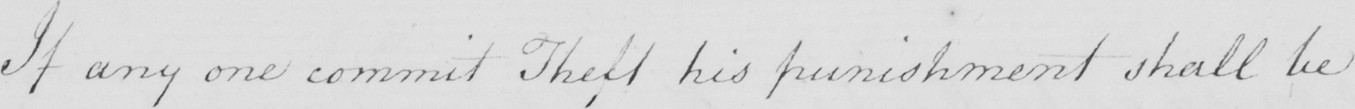What is written in this line of handwriting? If any one commit Theft his punishment shall be 